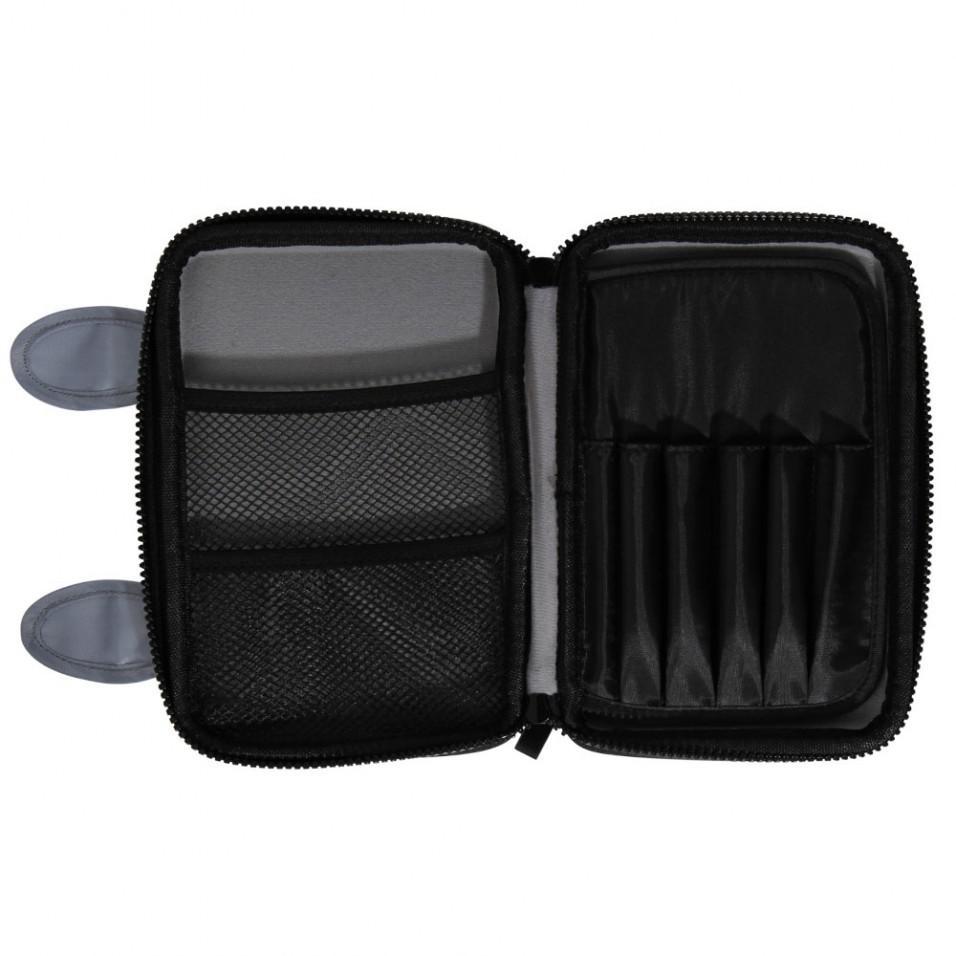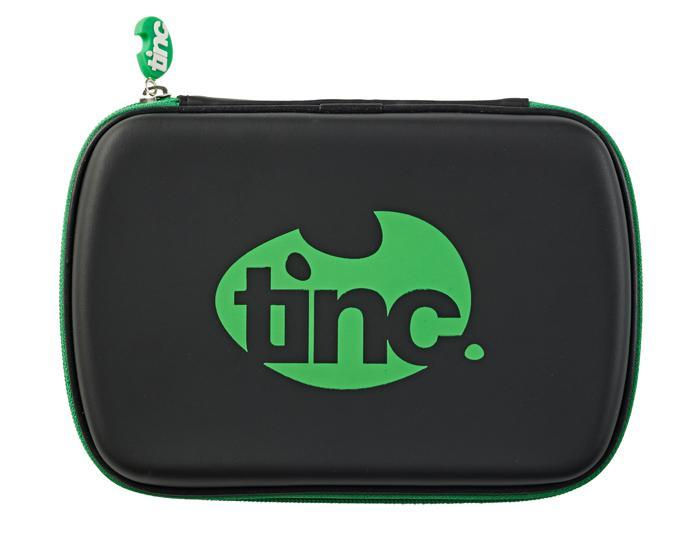The first image is the image on the left, the second image is the image on the right. For the images displayed, is the sentence "The black pencil case on the left is closed and has raised dots on its front, and the case on the right is also closed." factually correct? Answer yes or no. No. The first image is the image on the left, the second image is the image on the right. Given the left and right images, does the statement "there is a pencil pouch with raised bumps in varying sizes on it" hold true? Answer yes or no. No. 